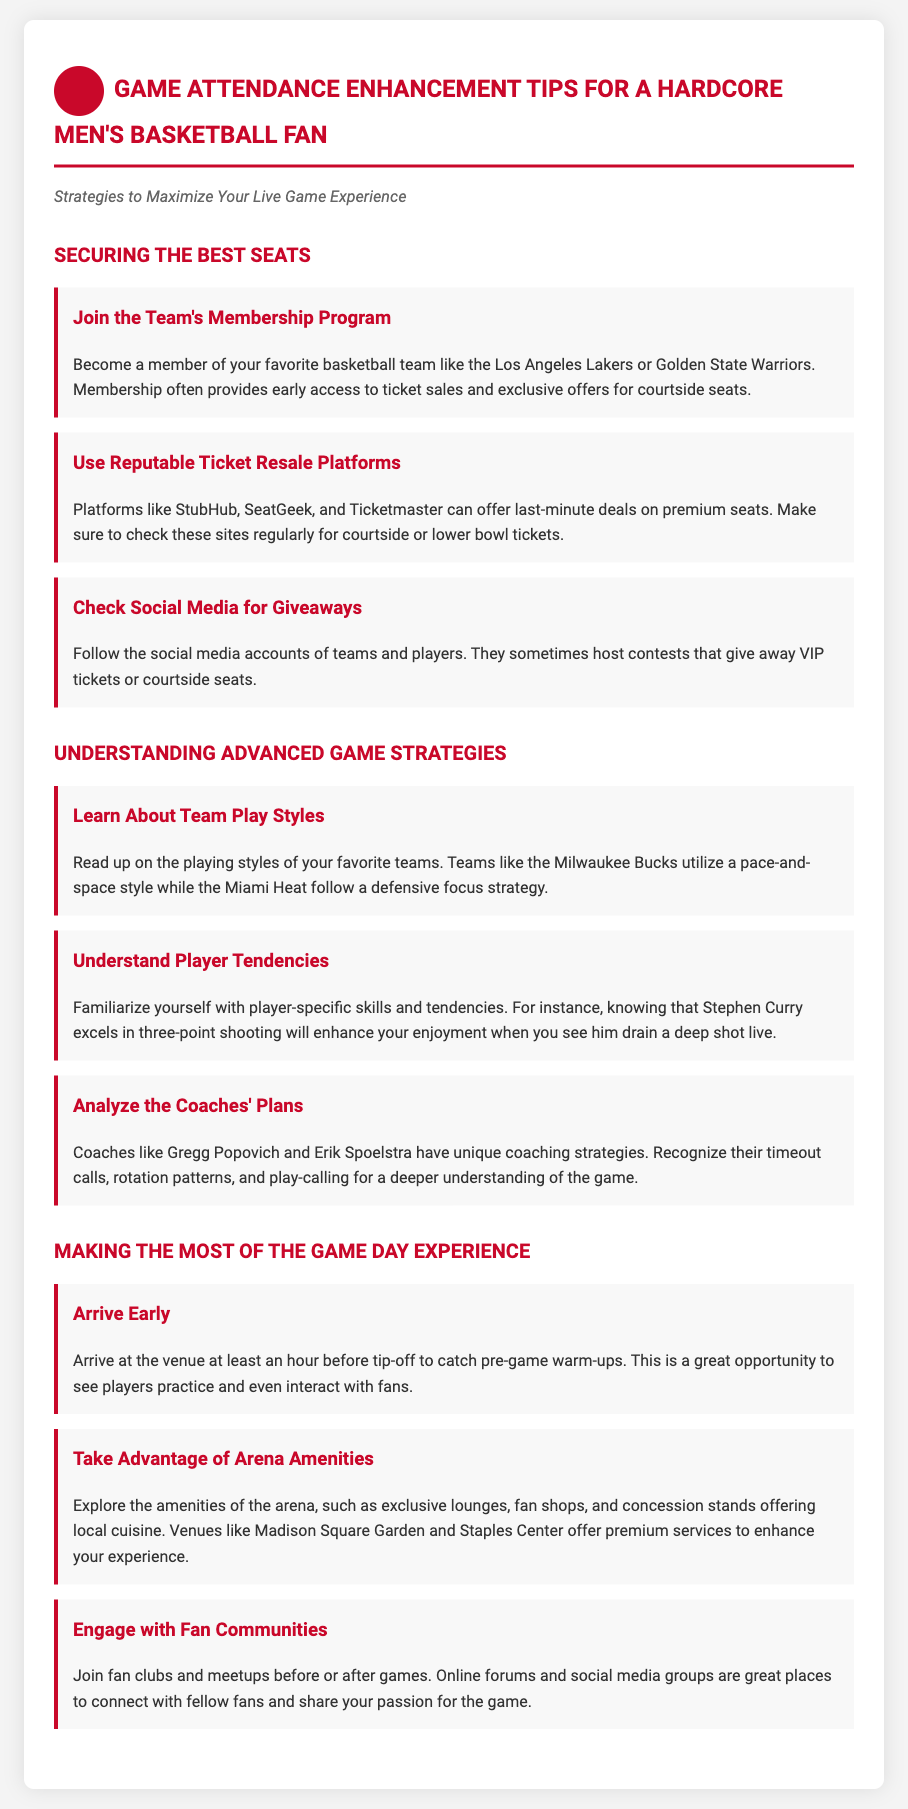What is the title of the document? The title is located at the top of the document and describes the content focused on enhancing game attendance for basketball fans.
Answer: Basketball Fan's Game Attendance Guide How can you get early access to ticket sales? The document mentions joining the team's membership program as a way to gain early access to ticket sales.
Answer: Team's membership program Name one ticket resale platform mentioned in the document. The document lists specific platforms where premium seats can be found. One of them is StubHub.
Answer: StubHub What should you arrive at the venue before? The document advises arriving early to catch a specific event that occurs before the game's start.
Answer: Tip-off Who is known for their defensive focus strategy? The document discusses various teams and their playing styles, mentioning a team known for particular strategies.
Answer: Miami Heat What is one way to engage with other fans? The document suggests ways to connect with fellow fans, highlighting a specific avenue for engagement.
Answer: Fan clubs and meetups What color is used for headings in the document? The document specifies a color used for headings that is bright and stands out.
Answer: Red Which venue is noted for premium services? The document highlights certain venues that offer enhanced experiences, naming one specifically known for its amenities.
Answer: Madison Square Garden 